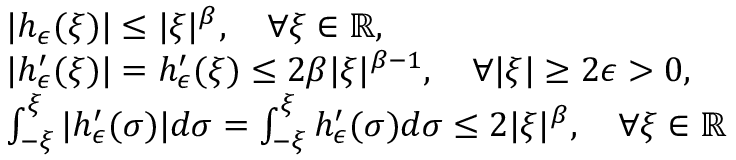<formula> <loc_0><loc_0><loc_500><loc_500>\begin{array} { r l } & { | h _ { \epsilon } ( \xi ) | \leq | \xi | ^ { \beta } , \quad \forall \xi \in \mathbb { R } , } \\ & { | h _ { \epsilon } ^ { \prime } ( \xi ) | = h _ { \epsilon } ^ { \prime } ( \xi ) \leq 2 \beta | \xi | ^ { \beta - 1 } , \quad \forall | \xi | \geq 2 \epsilon > 0 , } \\ & { \int _ { - \xi } ^ { \xi } | h _ { \epsilon } ^ { \prime } ( \sigma ) | d \sigma = \int _ { - \xi } ^ { \xi } h _ { \epsilon } ^ { \prime } ( \sigma ) d \sigma \leq 2 | \xi | ^ { \beta } , \quad \forall \xi \in \mathbb { R } } \end{array}</formula> 